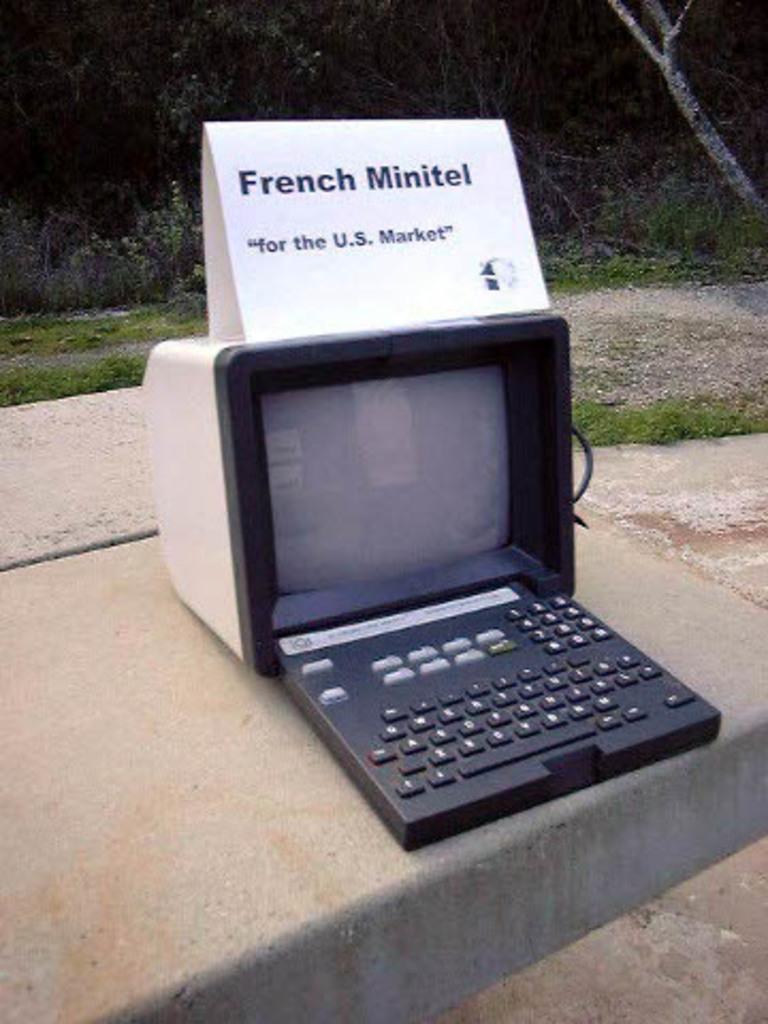What market is this for?
Provide a succinct answer. U.s. What is the name of this device?
Provide a succinct answer. French minitel. 